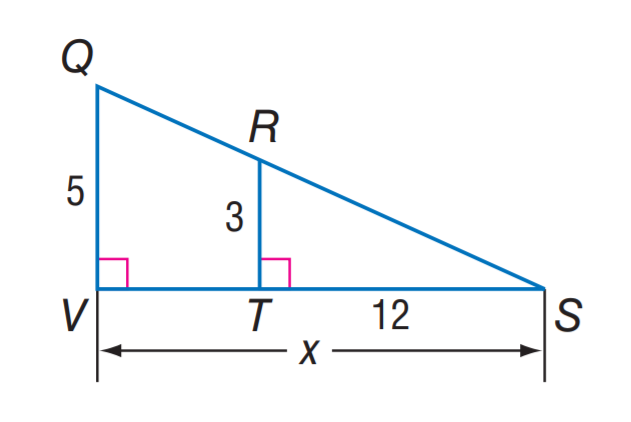Answer the mathemtical geometry problem and directly provide the correct option letter.
Question: Find V S.
Choices: A: 5 B: 12 C: 15 D: 20 D 